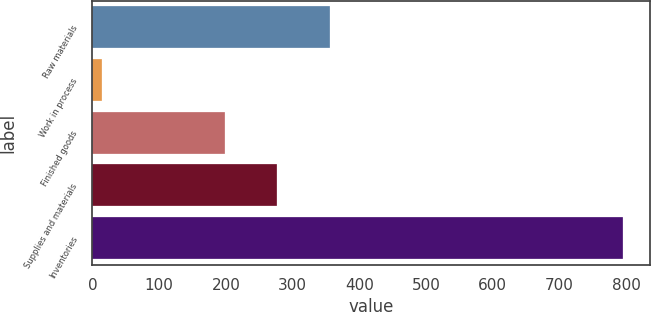Convert chart. <chart><loc_0><loc_0><loc_500><loc_500><bar_chart><fcel>Raw materials<fcel>Work in process<fcel>Finished goods<fcel>Supplies and materials<fcel>Inventories<nl><fcel>355.34<fcel>13.9<fcel>199<fcel>277.17<fcel>795.6<nl></chart> 